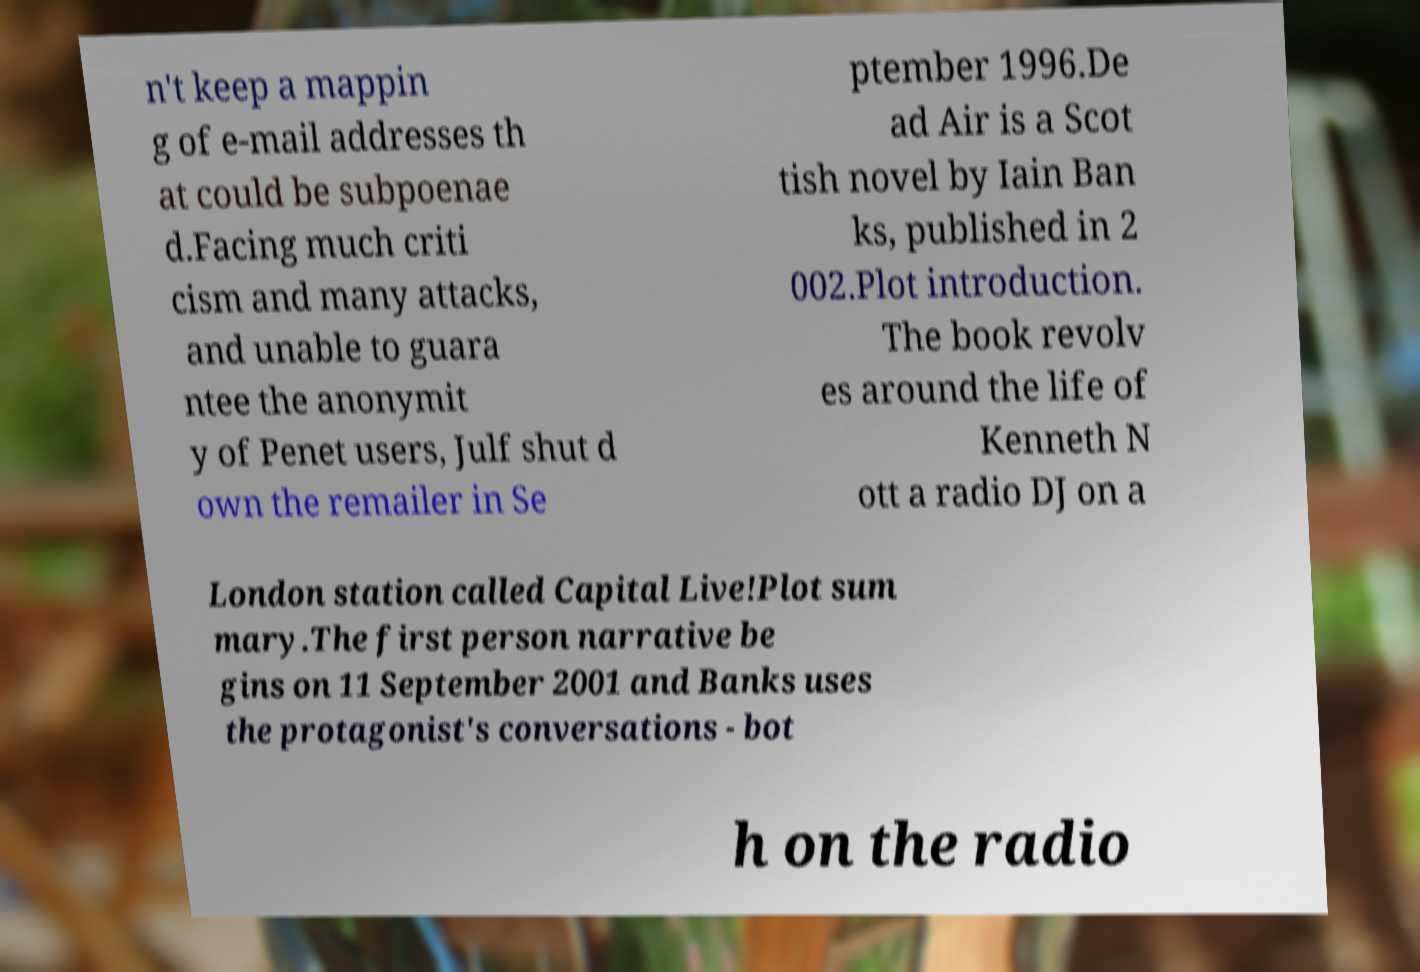Could you extract and type out the text from this image? n't keep a mappin g of e-mail addresses th at could be subpoenae d.Facing much criti cism and many attacks, and unable to guara ntee the anonymit y of Penet users, Julf shut d own the remailer in Se ptember 1996.De ad Air is a Scot tish novel by Iain Ban ks, published in 2 002.Plot introduction. The book revolv es around the life of Kenneth N ott a radio DJ on a London station called Capital Live!Plot sum mary.The first person narrative be gins on 11 September 2001 and Banks uses the protagonist's conversations - bot h on the radio 